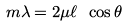<formula> <loc_0><loc_0><loc_500><loc_500>m \lambda = 2 \mu \ell \ \cos \theta</formula> 